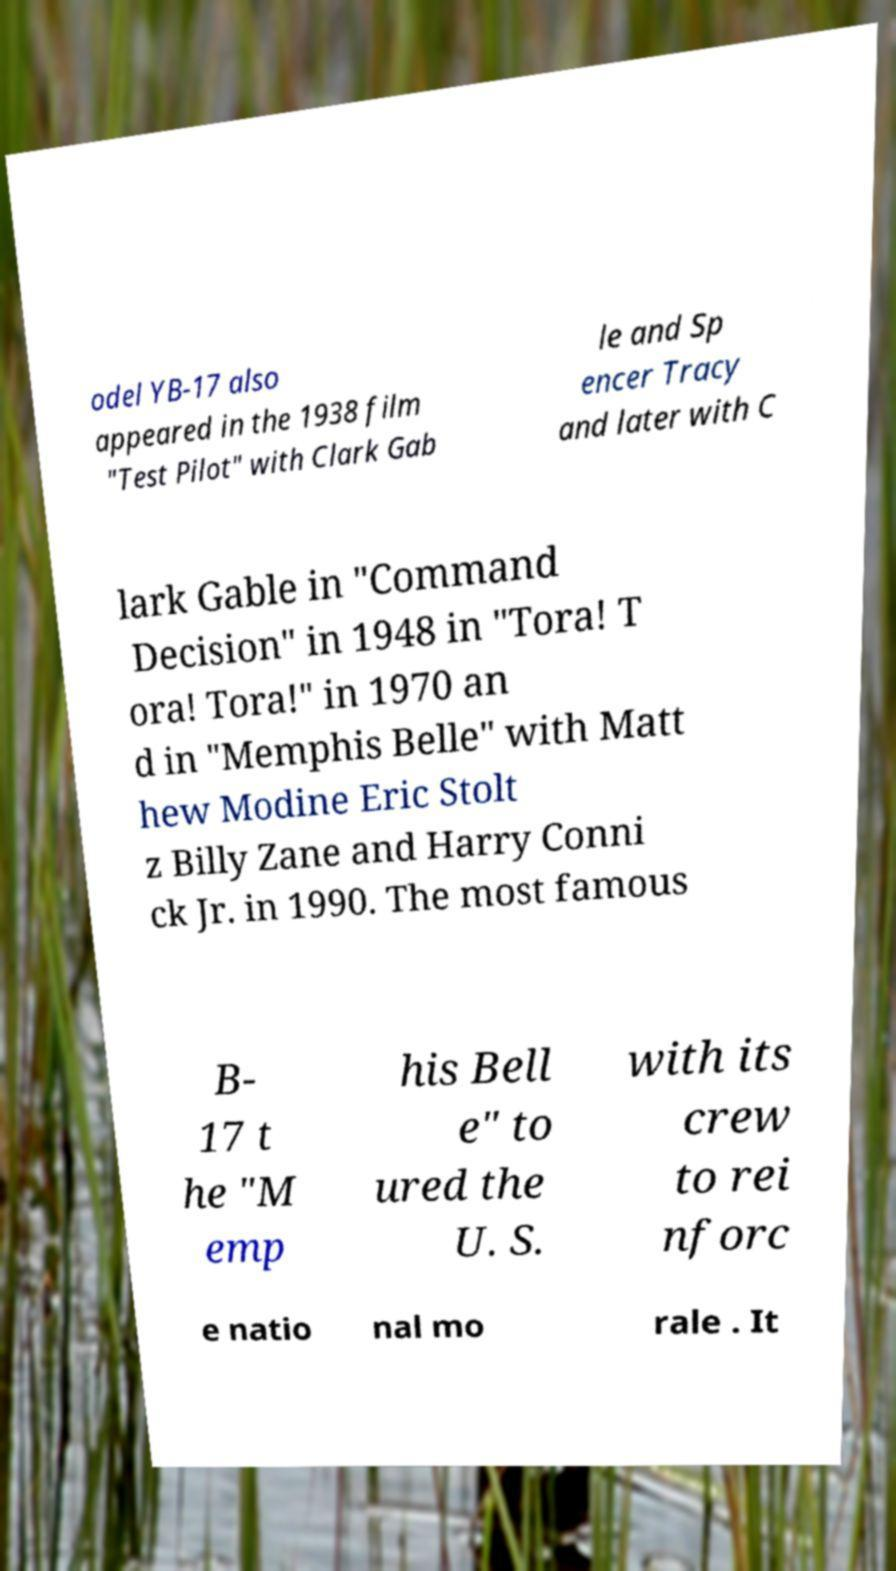Can you read and provide the text displayed in the image?This photo seems to have some interesting text. Can you extract and type it out for me? odel YB-17 also appeared in the 1938 film "Test Pilot" with Clark Gab le and Sp encer Tracy and later with C lark Gable in "Command Decision" in 1948 in "Tora! T ora! Tora!" in 1970 an d in "Memphis Belle" with Matt hew Modine Eric Stolt z Billy Zane and Harry Conni ck Jr. in 1990. The most famous B- 17 t he "M emp his Bell e" to ured the U. S. with its crew to rei nforc e natio nal mo rale . It 